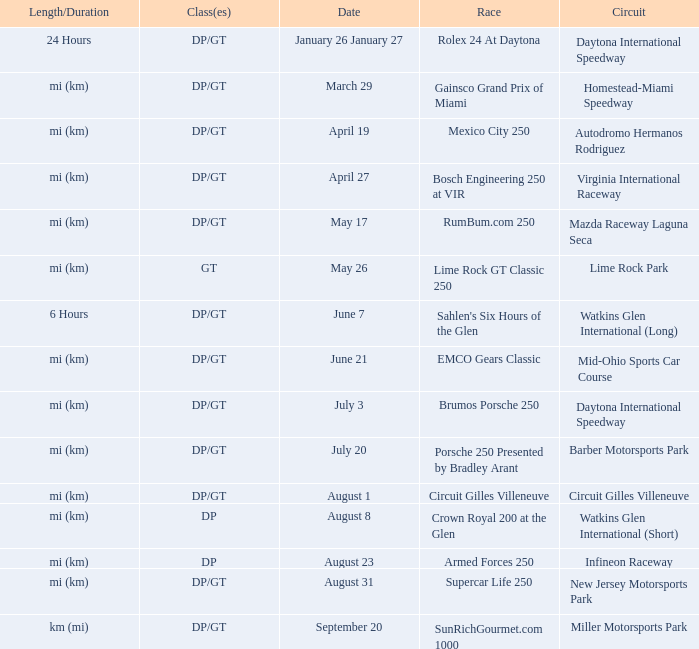What is the length and duration of the race on April 19? Mi (km). 